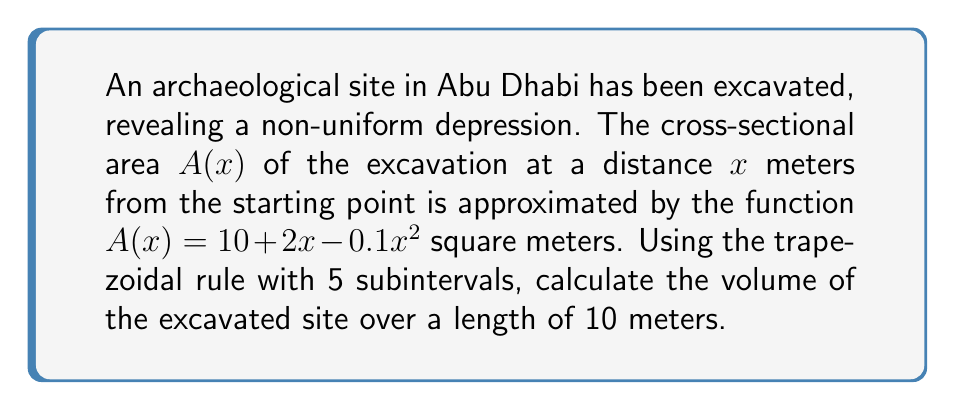Give your solution to this math problem. To calculate the volume using numerical integration, we'll apply the trapezoidal rule:

1) The trapezoidal rule for n subintervals is given by:
   $$\int_{a}^{b} f(x)dx \approx \frac{h}{2}[f(x_0) + 2f(x_1) + 2f(x_2) + ... + 2f(x_{n-1}) + f(x_n)]$$
   where $h = \frac{b-a}{n}$

2) In our case:
   $a = 0$, $b = 10$, $n = 5$, so $h = \frac{10-0}{5} = 2$

3) We need to evaluate $A(x)$ at $x = 0, 2, 4, 6, 8, 10$:
   $A(0) = 10 + 2(0) - 0.1(0)^2 = 10$
   $A(2) = 10 + 2(2) - 0.1(2)^2 = 13.6$
   $A(4) = 10 + 2(4) - 0.1(4)^2 = 16.4$
   $A(6) = 10 + 2(6) - 0.1(6)^2 = 18.4$
   $A(8) = 10 + 2(8) - 0.1(8)^2 = 19.6$
   $A(10) = 10 + 2(10) - 0.1(10)^2 = 20$

4) Applying the trapezoidal rule:
   $$V \approx \frac{2}{2}[10 + 2(13.6) + 2(16.4) + 2(18.4) + 2(19.6) + 20]$$
   $$V \approx 1[10 + 27.2 + 32.8 + 36.8 + 39.2 + 20]$$
   $$V \approx 166 \text{ cubic meters}$$
Answer: 166 m³ 